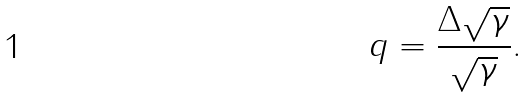<formula> <loc_0><loc_0><loc_500><loc_500>q = \frac { \Delta \sqrt { \gamma } } { \sqrt { \gamma } } .</formula> 